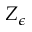<formula> <loc_0><loc_0><loc_500><loc_500>Z _ { \epsilon }</formula> 